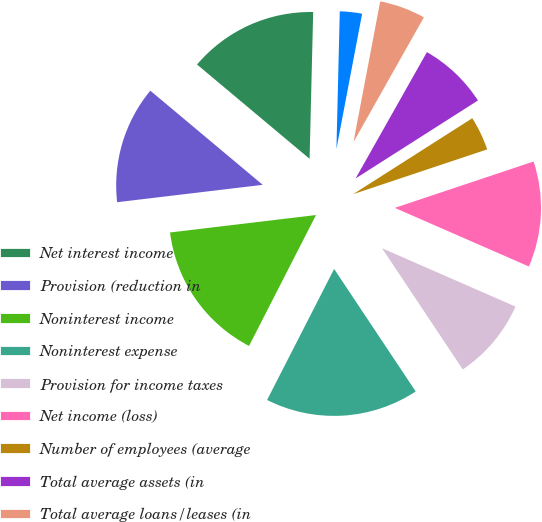<chart> <loc_0><loc_0><loc_500><loc_500><pie_chart><fcel>Net interest income<fcel>Provision (reduction in<fcel>Noninterest income<fcel>Noninterest expense<fcel>Provision for income taxes<fcel>Net income (loss)<fcel>Number of employees (average<fcel>Total average assets (in<fcel>Total average loans/leases (in<fcel>Total average deposits (in<nl><fcel>14.29%<fcel>12.99%<fcel>15.58%<fcel>16.88%<fcel>9.09%<fcel>11.69%<fcel>3.9%<fcel>7.79%<fcel>5.19%<fcel>2.6%<nl></chart> 